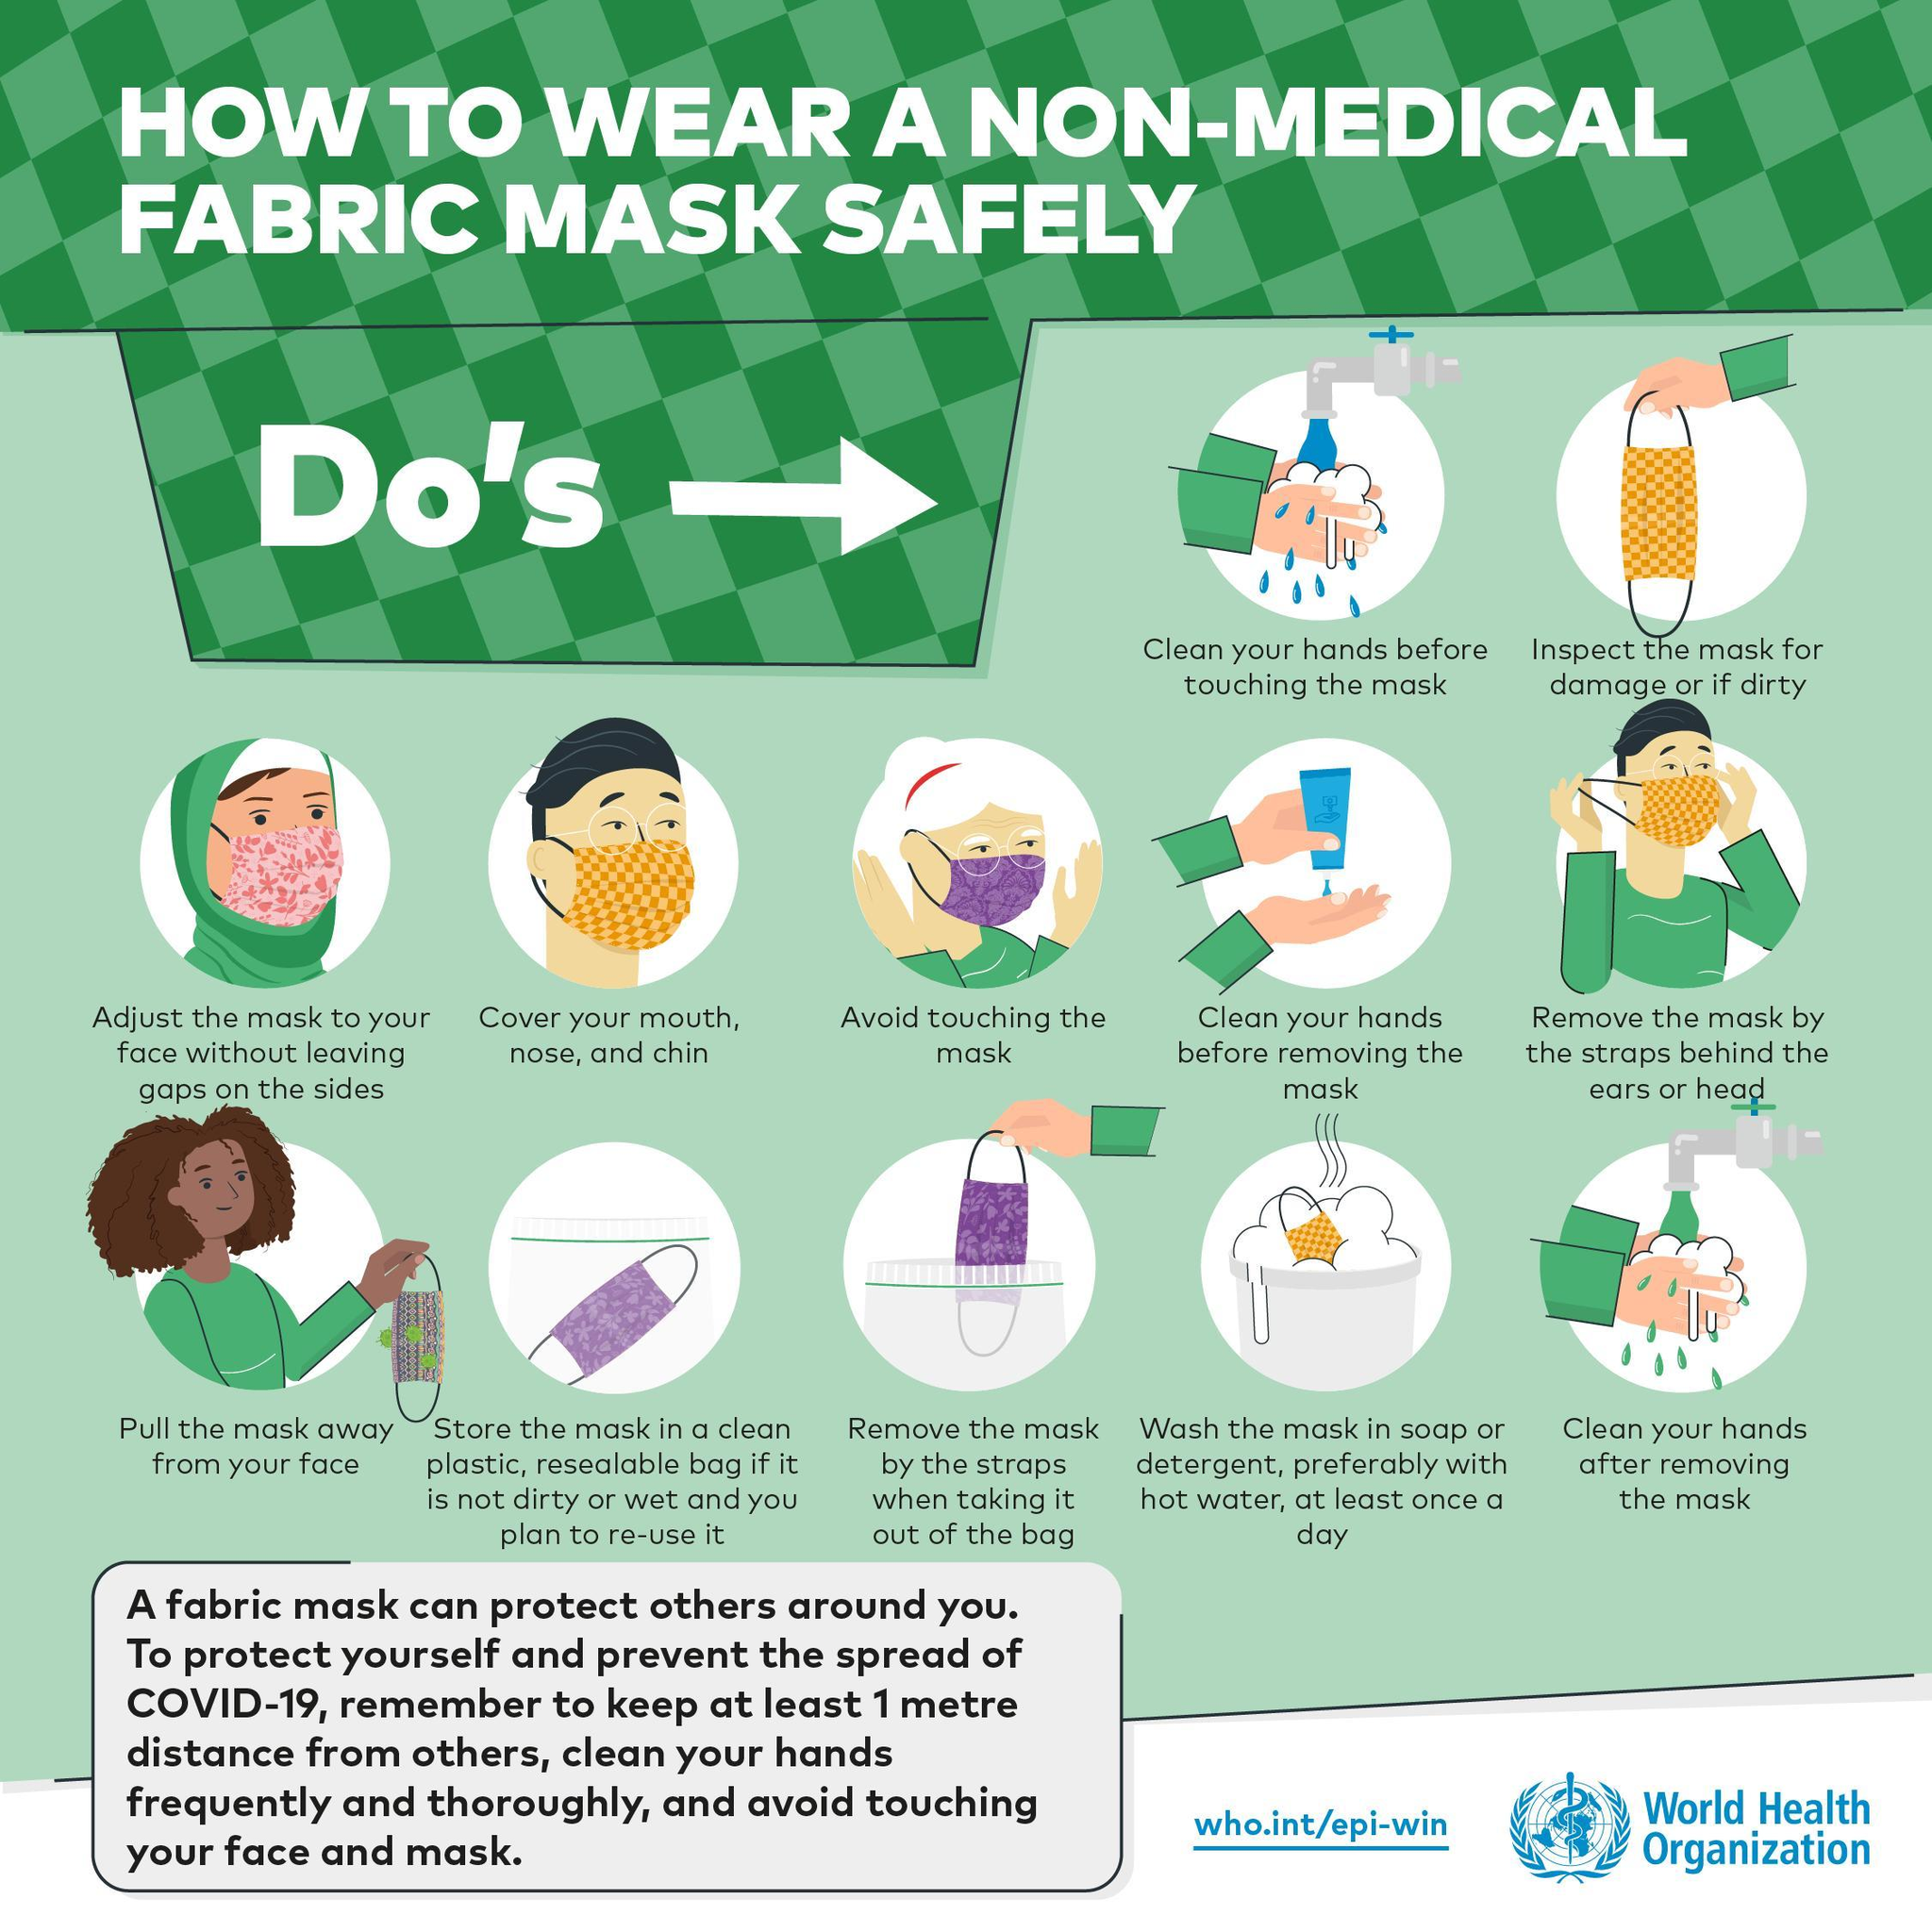How many pink coloured masks are shown?
Answer the question with a short phrase. 1 How many people are shown in the infographic? 5 How many masks are shown in the infographic? 9 How many Do's are shown in the infographic? 12 What is the colour of the mask worn by the old lady- yellow, pink or purple? purple How many masks shown are yellow in colour? 4 